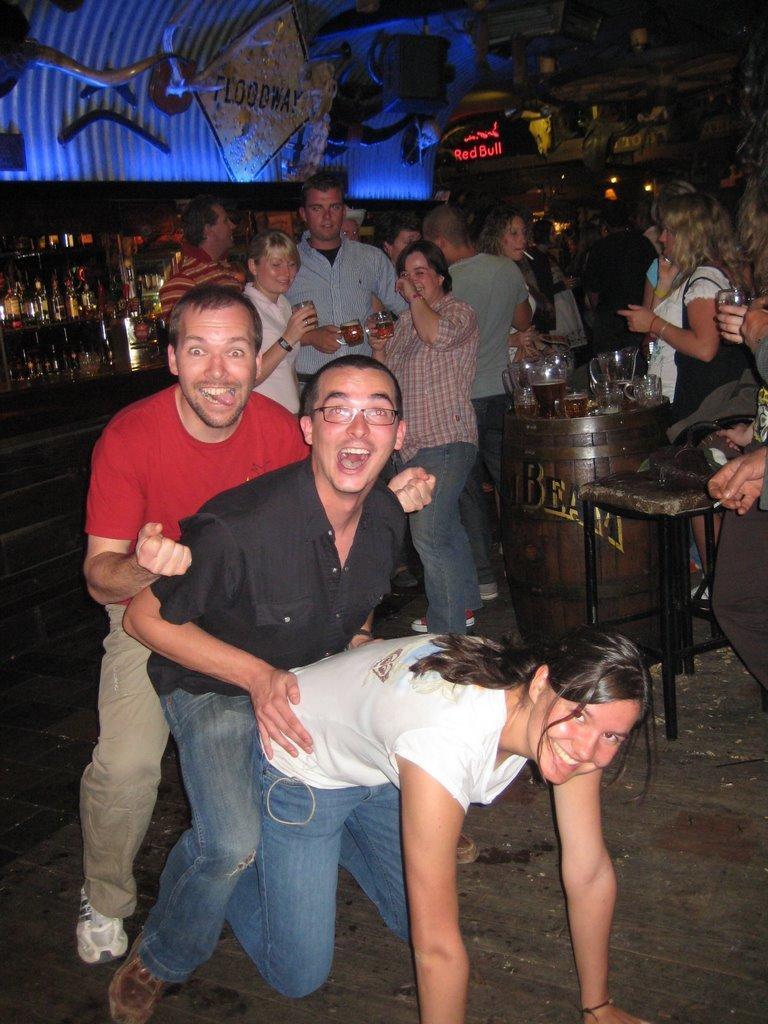Please provide a concise description of this image. In this image we can see some group of persons standing and holding some drinks in their hands and in the background of the image there are some bottles which are arranged in shelves and there are some paintings attached to the wall. 